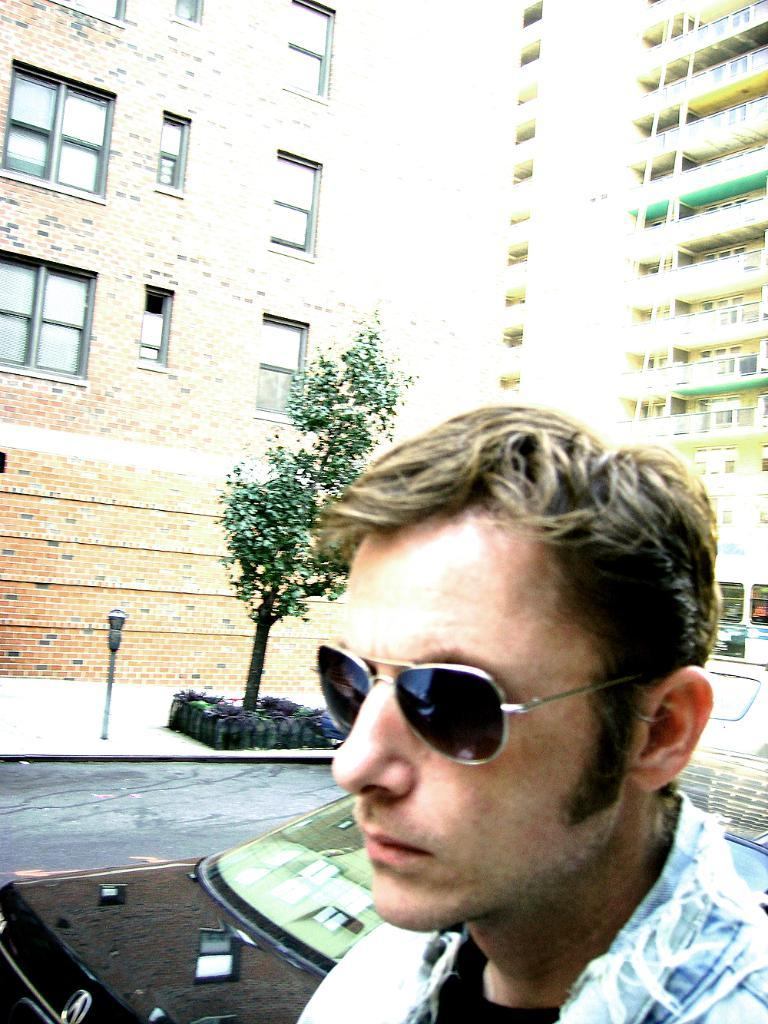What can be seen in the image? There is a person in the image. What is the person wearing? The person is wearing goggles. What can be seen in the background of the image? There are vehicles visible on the road, a tree, an electric pole, and buildings in the background. What type of tooth is visible in the image? There is no tooth visible in the image. Is the person wearing a sock in the image? The provided facts do not mention any socks, so it cannot be determined if the person is wearing a sock in the image. 